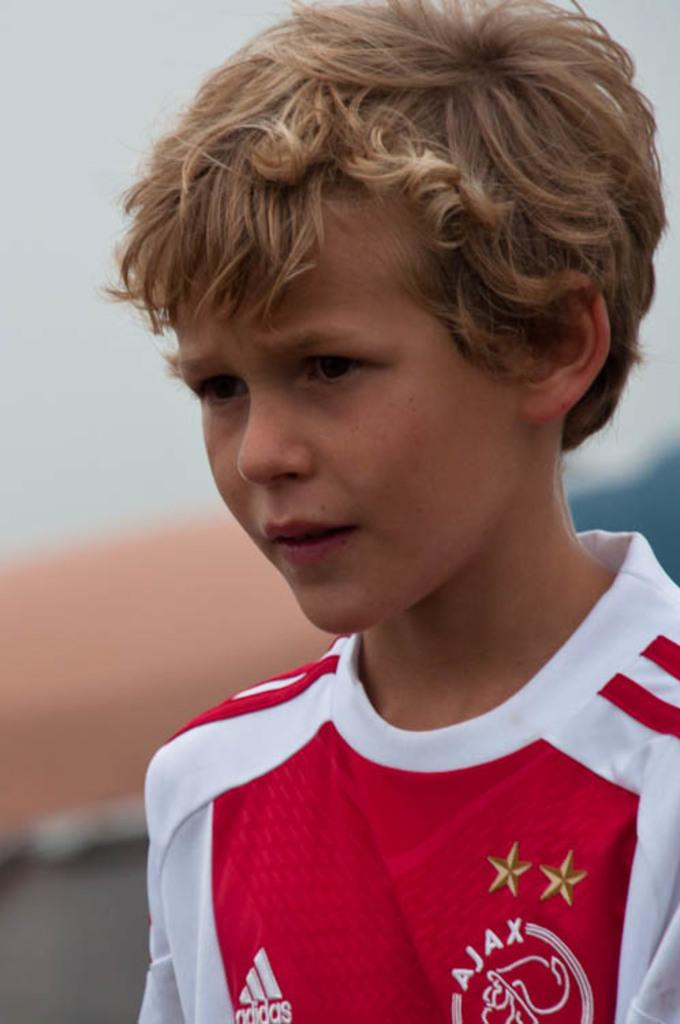<image>
Create a compact narrative representing the image presented. a boy wearing a red adidas shirt is looking at something 